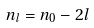Convert formula to latex. <formula><loc_0><loc_0><loc_500><loc_500>n _ { l } = n _ { 0 } - 2 l</formula> 